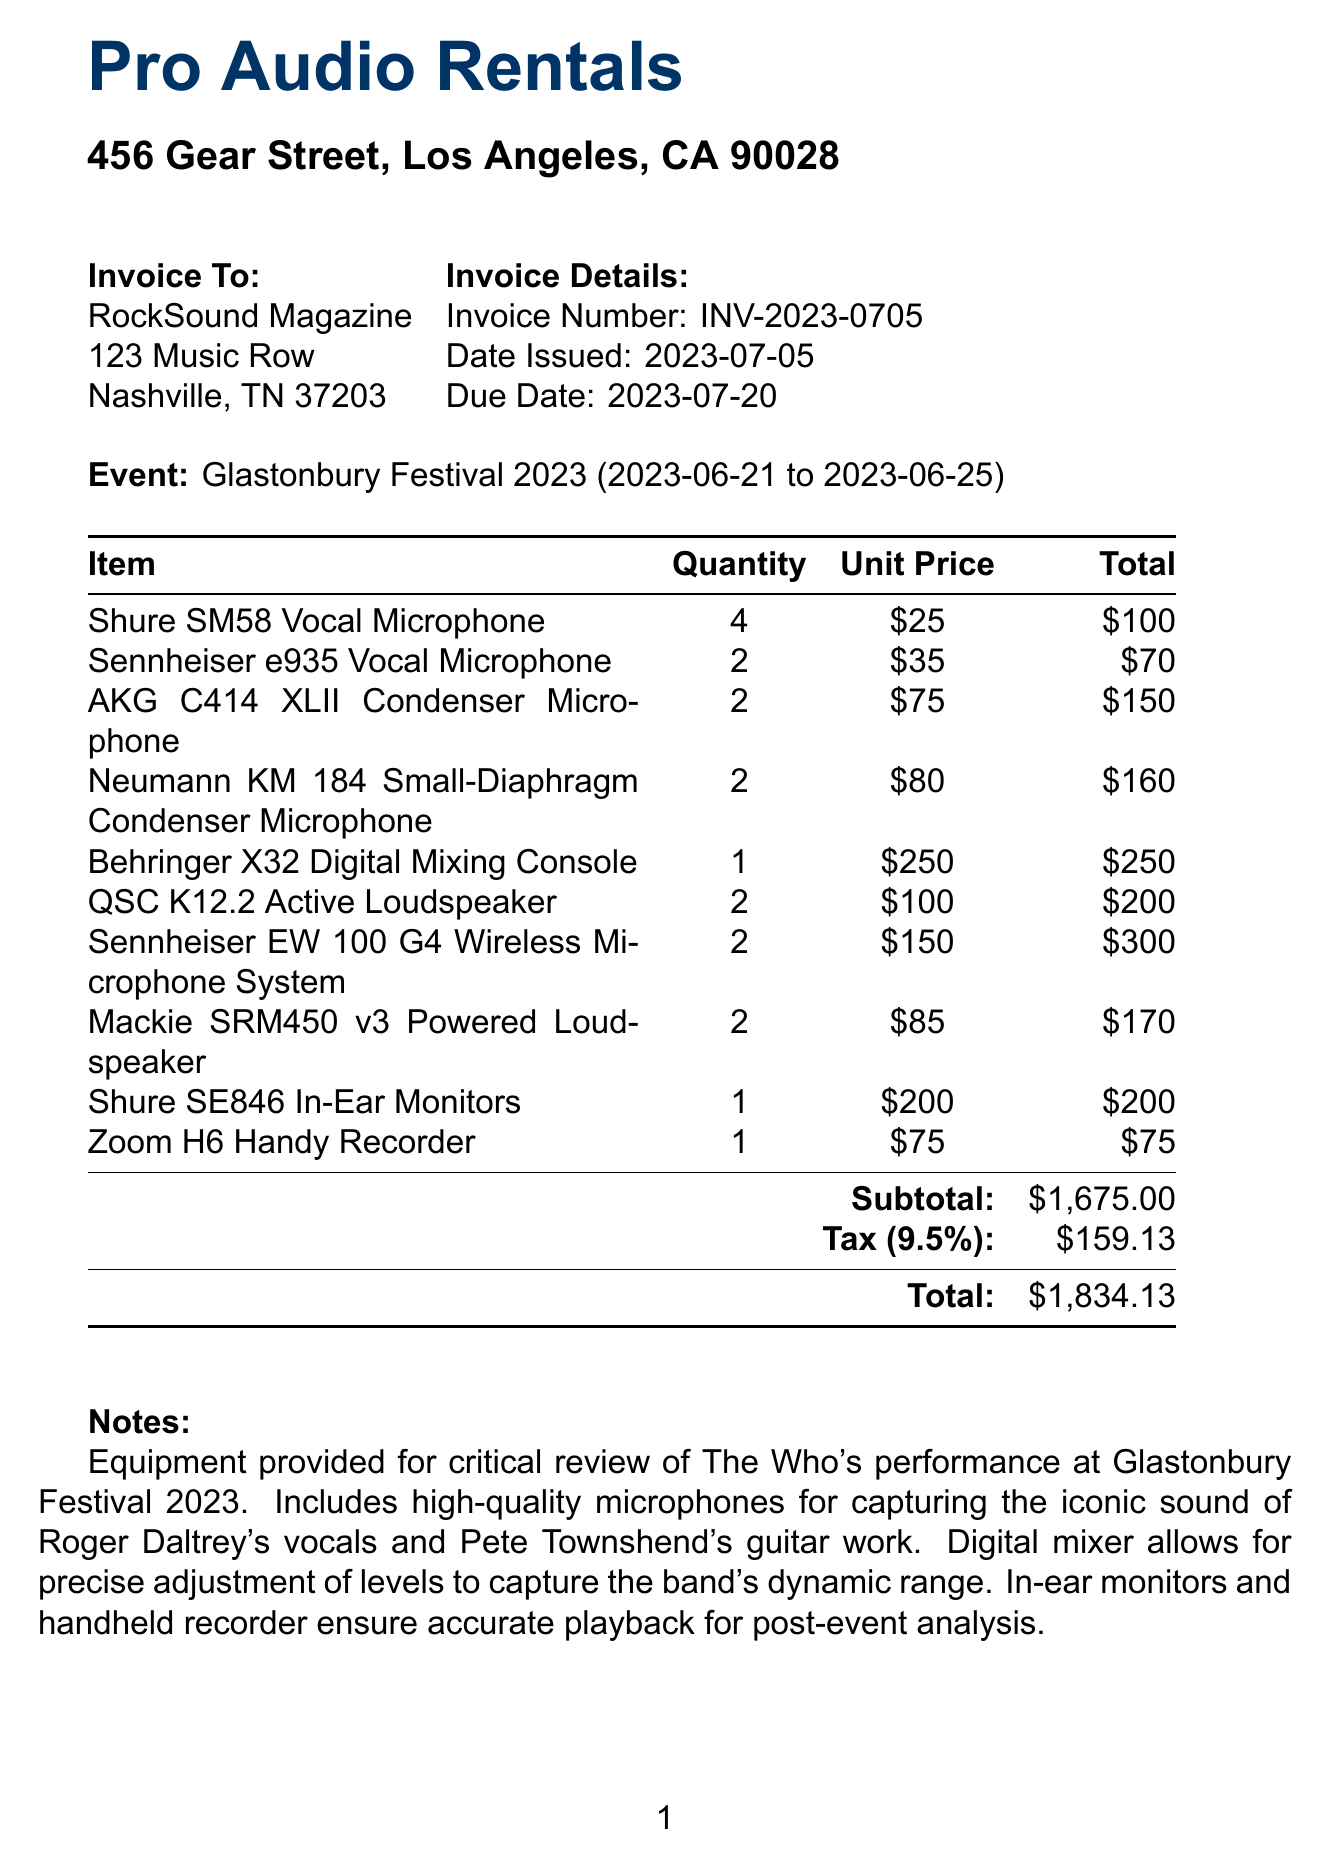What is the invoice number? The invoice number is a unique identifier for this invoice, listed as INV-2023-0705.
Answer: INV-2023-0705 Who is the vendor? The vendor refers to the company providing the equipment rental services, which is Pro Audio Rentals.
Answer: Pro Audio Rentals What is the due date? The due date indicates when payment is required, listed as July 20, 2023.
Answer: July 20, 2023 How many Shure SM58 microphones were rented? The quantity of Shure SM58 microphones rented is specified in the line items of the invoice.
Answer: 4 What is the subtotal amount? The subtotal is the total amount before tax and is specified as $1675.00.
Answer: $1,675.00 What is the tax rate applied? The tax rate indicates the percentage charged on the subtotal, which is listed as 9.5%.
Answer: 9.5% What performance is this invoice related to? This invoice is specifically for the review of a performance event, noted as The Who's performance.
Answer: The Who's performance What equipment was used for capturing vocals? The document lists various microphones used for vocal capture, including the Shure SM58.
Answer: Shure SM58 How many different types of microphones are listed? The document enumerates multiple types of microphones included in the rental, reflecting the variety available.
Answer: 5 